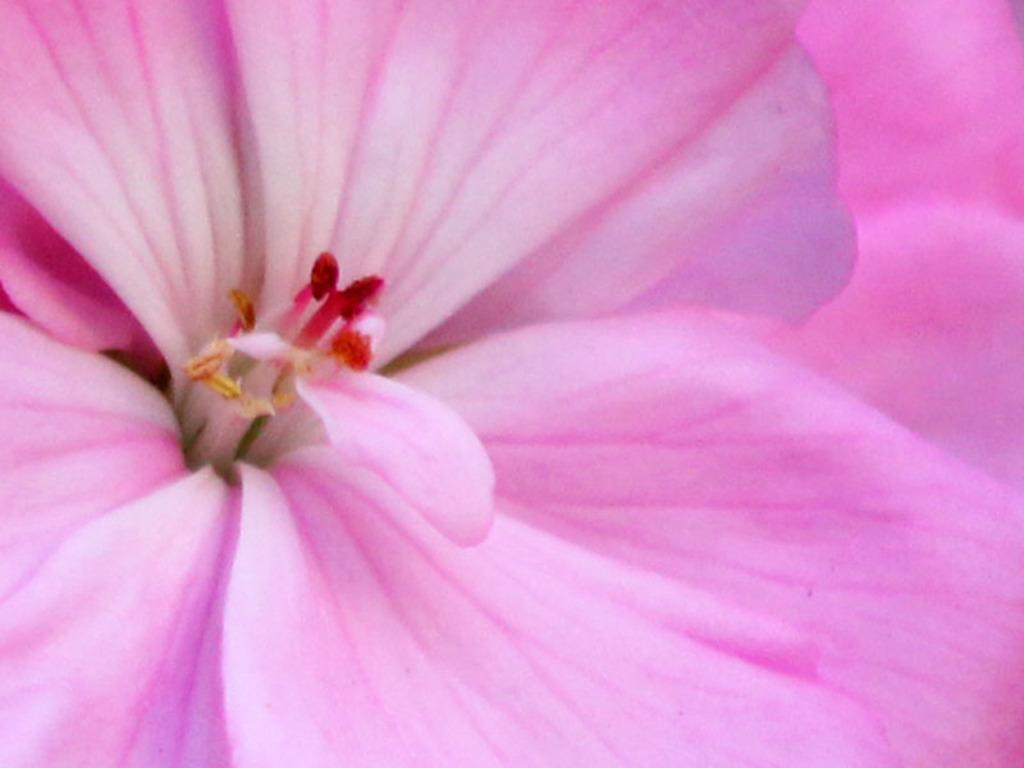Can you describe this image briefly? In this image, we can see a flower. 